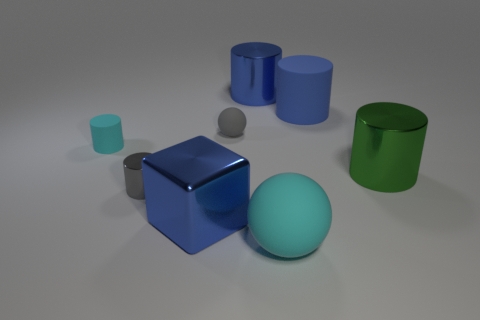Are there any gray rubber things that have the same shape as the large green shiny object?
Offer a terse response. No. Is the gray object behind the large green cylinder made of the same material as the gray cylinder that is on the left side of the big shiny cube?
Your response must be concise. No. The tiny rubber thing that is the same color as the small metallic object is what shape?
Offer a very short reply. Sphere. What number of large cylinders have the same material as the green object?
Your response must be concise. 1. What color is the tiny ball?
Offer a very short reply. Gray. Does the tiny gray object in front of the cyan cylinder have the same shape as the rubber thing behind the gray ball?
Make the answer very short. Yes. There is a big metallic cylinder left of the blue matte object; what is its color?
Your answer should be very brief. Blue. Are there fewer green cylinders that are on the left side of the blue shiny cube than large green metal cylinders on the left side of the large cyan matte ball?
Keep it short and to the point. No. Is the material of the large block the same as the big ball?
Keep it short and to the point. No. What number of other things are there of the same size as the gray metallic object?
Give a very brief answer. 2. 